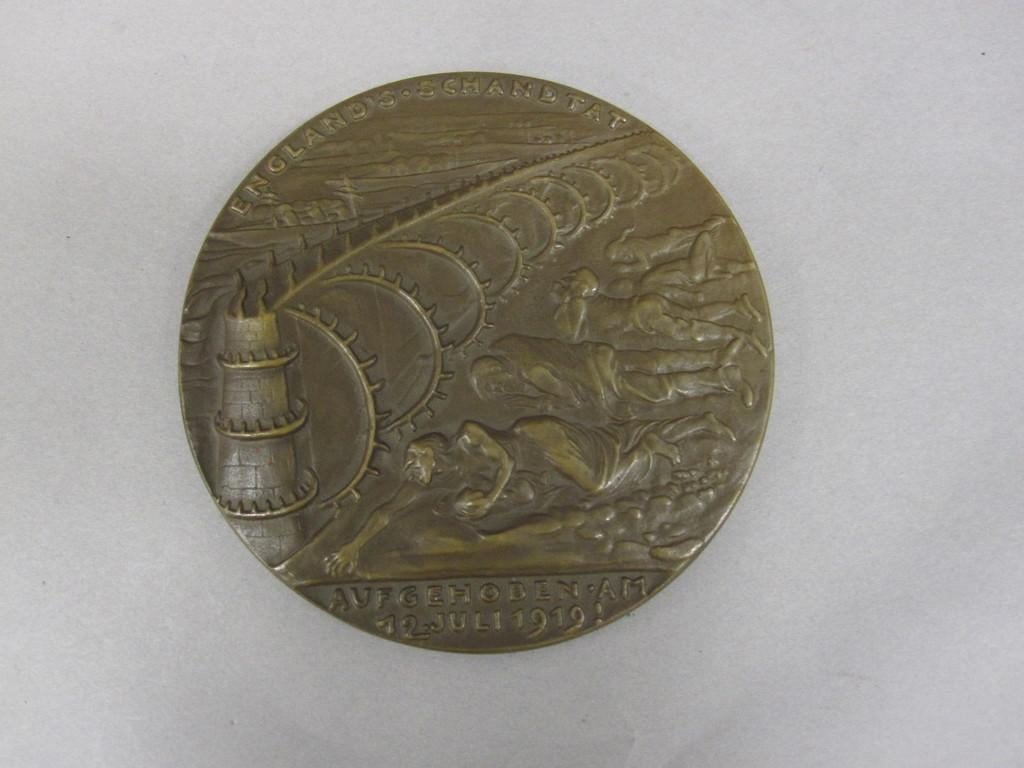<image>
Create a compact narrative representing the image presented. A coin that commemorates an event from 1919. 